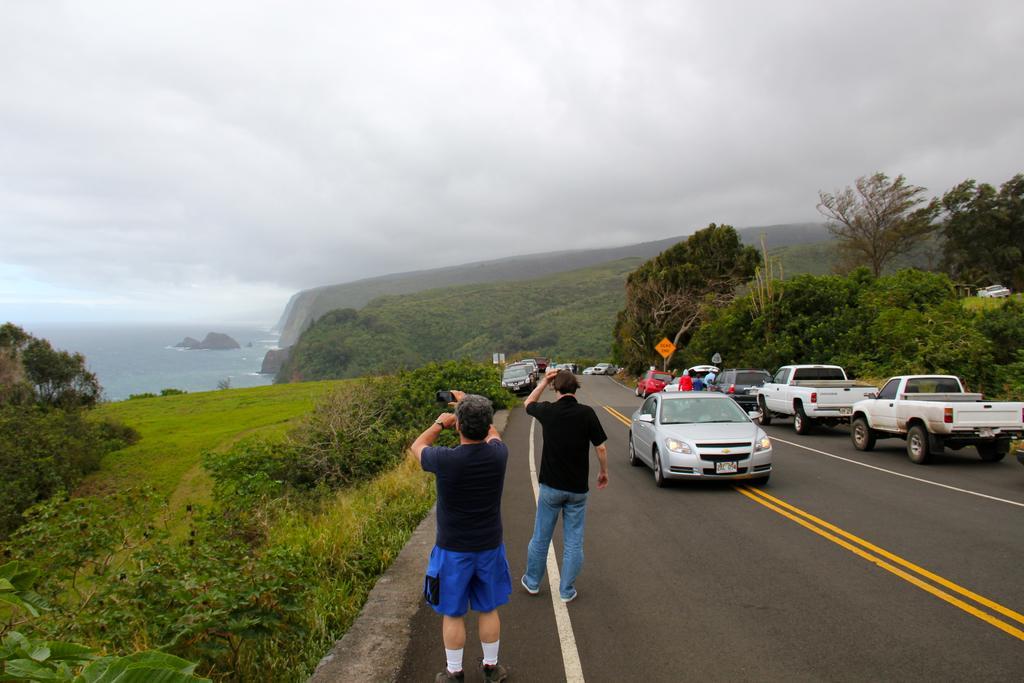Describe this image in one or two sentences. In this image there is the sky, there is sea, there are rocks, there are trees, there is tree truncated towards the left of the image, there are trees truncated towards the right of the image, there are plants, there is a plant truncated towards the bottom of the image, there is road, there are persons on the road, there is a person holding an object, there are vehicles on the road, there are boards, there is text on the boards, there are poles. 